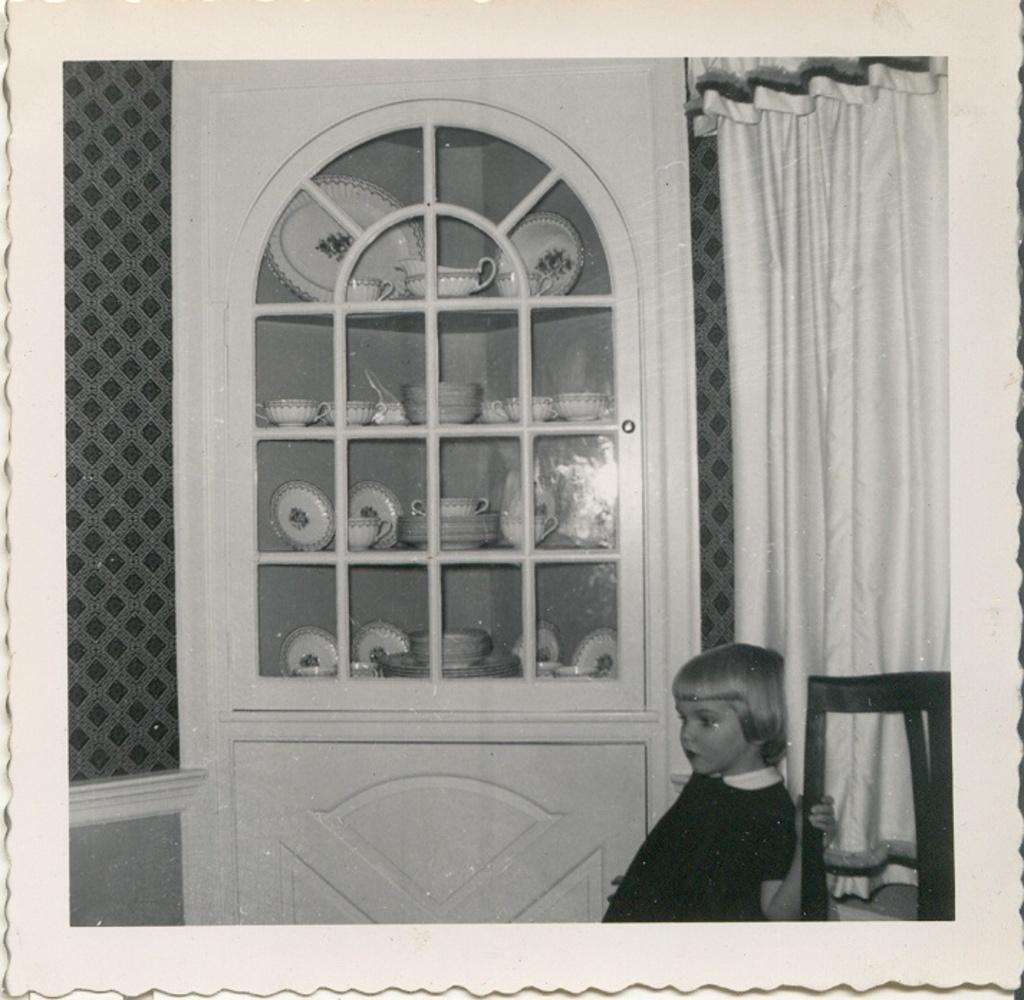Could you give a brief overview of what you see in this image? This is a black and white picture, there is a baby standing beside a chair in front of wall with curtain, in the middle there is a cupboard with cups,bowls,saucers in it. 